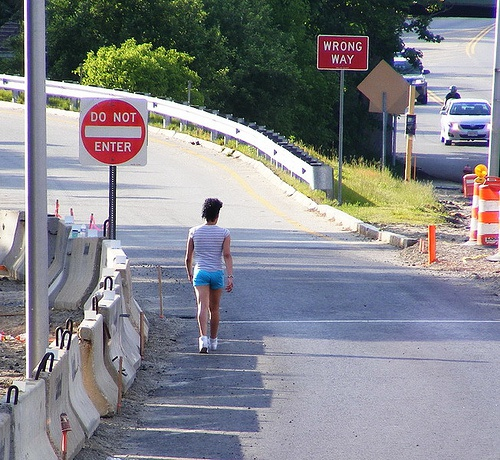Describe the objects in this image and their specific colors. I can see stop sign in black, darkgray, and brown tones, people in black, gray, and darkgray tones, car in black, white, blue, darkgray, and navy tones, car in black, navy, blue, and white tones, and people in black, navy, white, and gray tones in this image. 